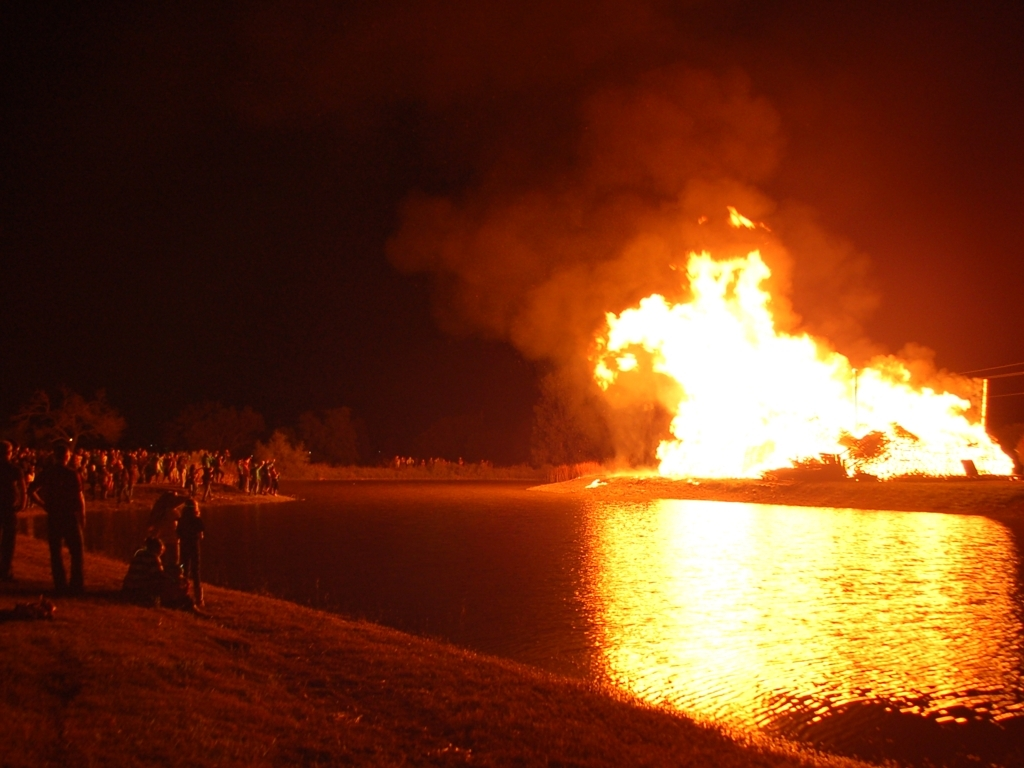What is happening in this image? The image depicts a large fire at night by a body of water with spectators gathered at a safe distance. The scale of the fire suggests it could be a controlled bonfire event or a large-scale emergency. 